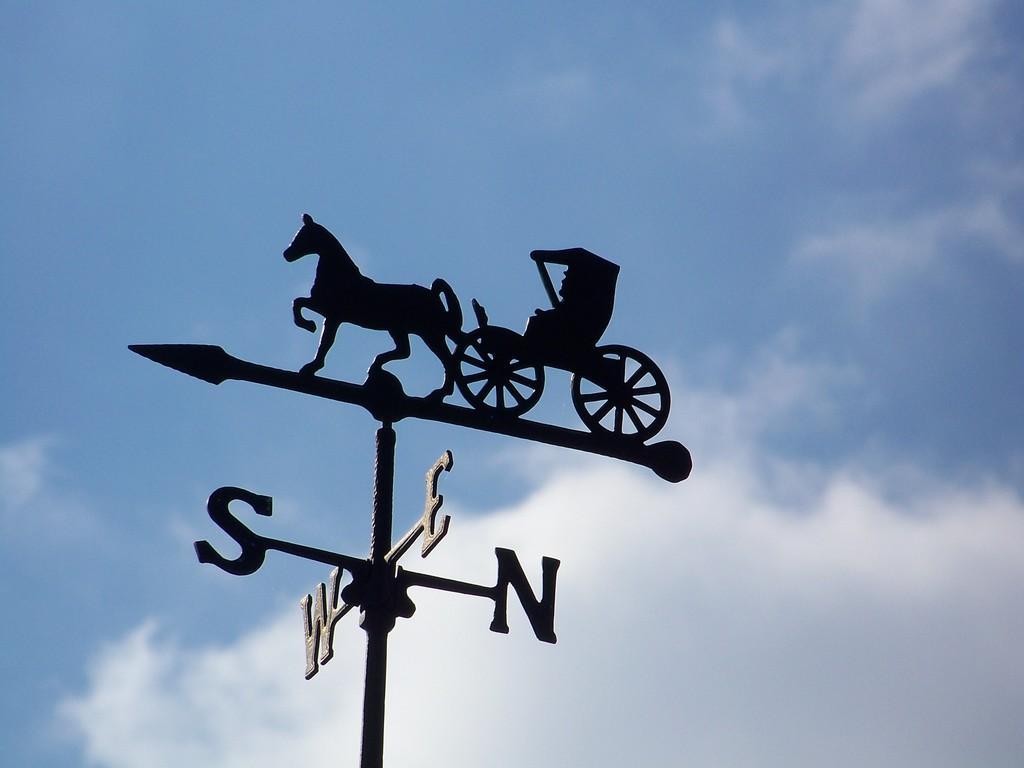Please provide a concise description of this image. In this image, we can see a direction pole. Here we can see a horse cart on the pole. Background there is a cloudy sky. 